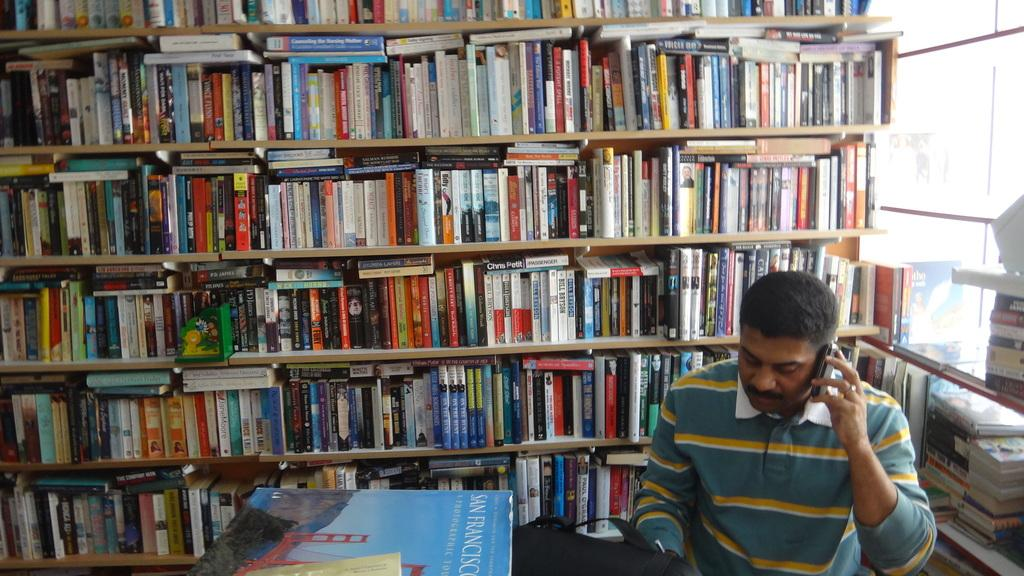<image>
Share a concise interpretation of the image provided. A book about San Francisco is sitting next to the man in the library. 